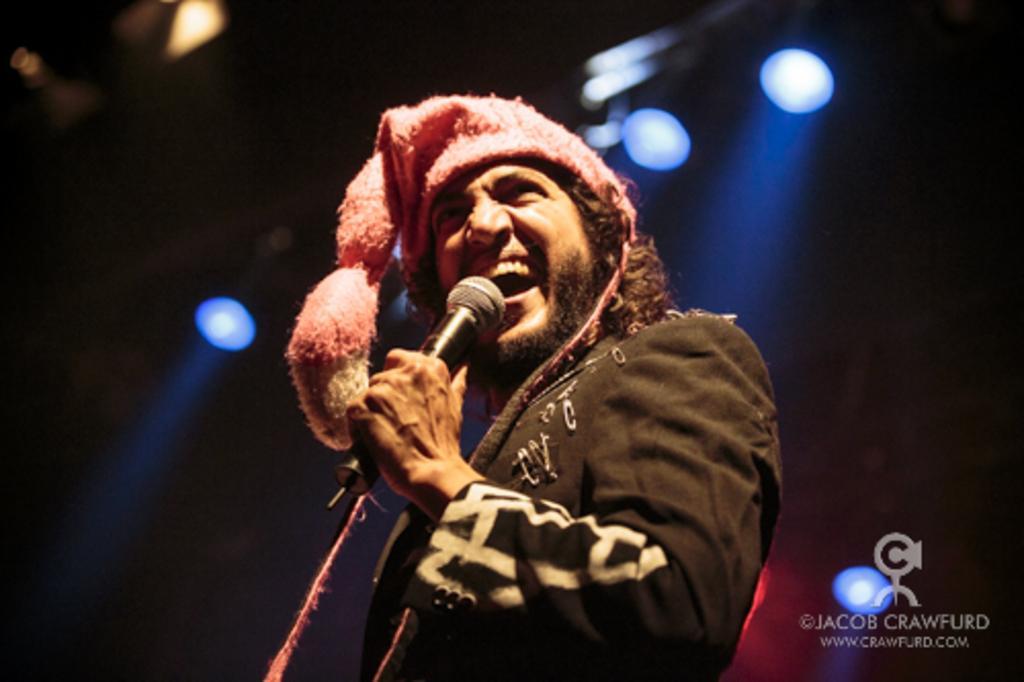Please provide a concise description of this image. In the picture we can see a man standing and holding a microphone and singing a song, he is wearing a cap and in the background, we can see a light which is focused on him, which are blue in color. 